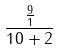Convert formula to latex. <formula><loc_0><loc_0><loc_500><loc_500>\frac { \frac { 9 } { 1 } } { 1 0 + 2 }</formula> 